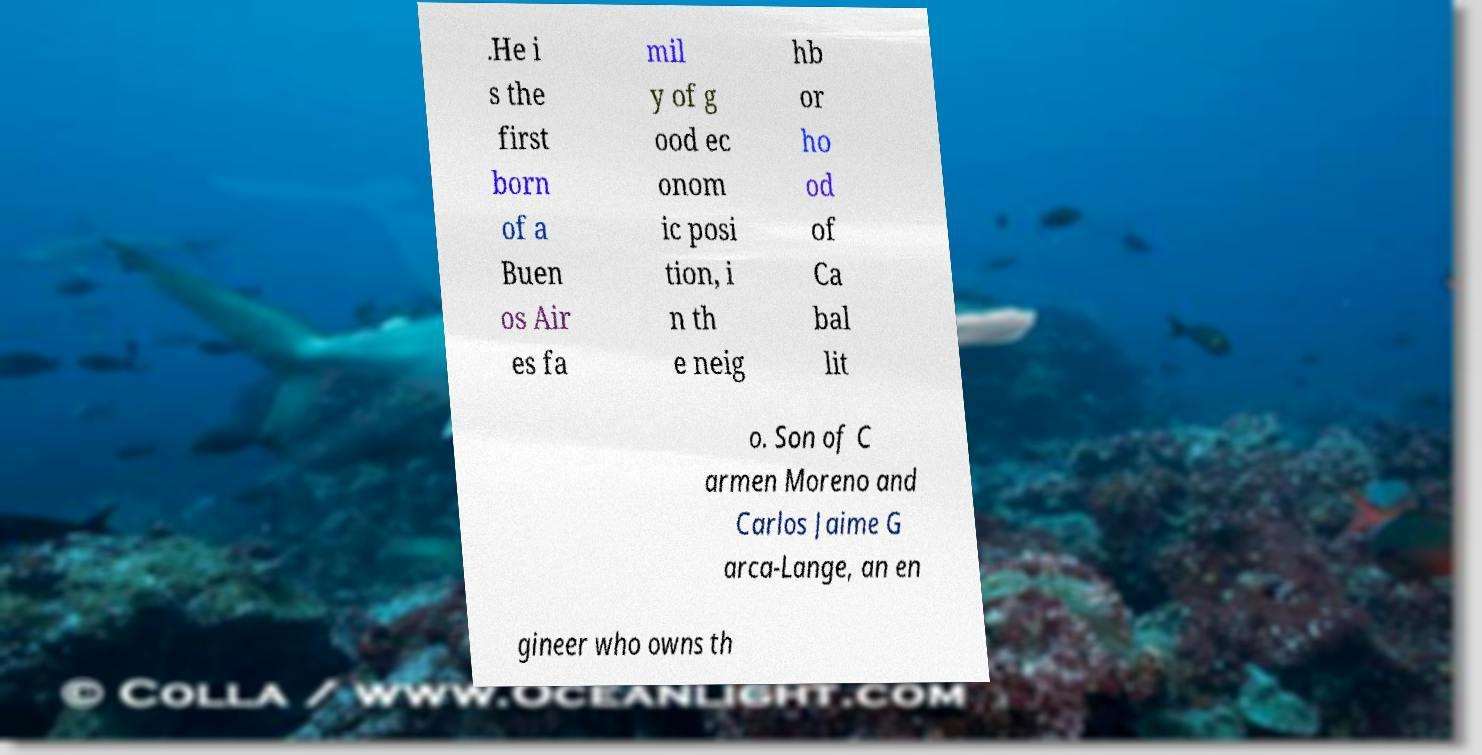Can you read and provide the text displayed in the image?This photo seems to have some interesting text. Can you extract and type it out for me? .He i s the first born of a Buen os Air es fa mil y of g ood ec onom ic posi tion, i n th e neig hb or ho od of Ca bal lit o. Son of C armen Moreno and Carlos Jaime G arca-Lange, an en gineer who owns th 